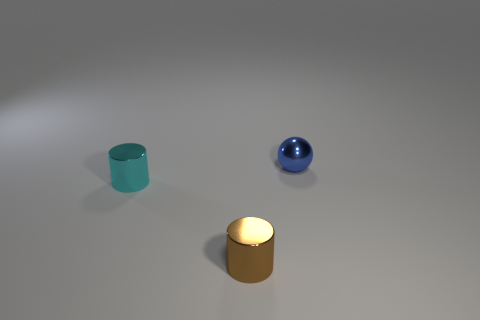What number of other objects are the same shape as the cyan thing?
Ensure brevity in your answer.  1. What is the shape of the brown object that is the same material as the blue ball?
Your response must be concise. Cylinder. Are there any cyan cylinders?
Make the answer very short. Yes. Are there fewer brown cylinders in front of the brown object than small cylinders in front of the tiny cyan cylinder?
Give a very brief answer. Yes. What is the shape of the small shiny object to the left of the brown cylinder?
Offer a very short reply. Cylinder. Is the blue ball made of the same material as the tiny cyan object?
Provide a succinct answer. Yes. Is there anything else that has the same material as the tiny cyan cylinder?
Your response must be concise. Yes. There is a small cyan thing that is the same shape as the small brown metal object; what is it made of?
Keep it short and to the point. Metal. Is the number of tiny blue balls on the left side of the small blue shiny object less than the number of tiny green shiny blocks?
Keep it short and to the point. No. There is a ball; what number of brown metal cylinders are behind it?
Ensure brevity in your answer.  0. 